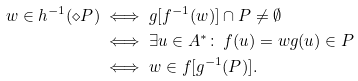Convert formula to latex. <formula><loc_0><loc_0><loc_500><loc_500>w \in h ^ { - 1 } ( \diamond P ) & \iff g [ f ^ { - 1 } ( w ) ] \cap P \neq \emptyset \\ & \iff \exists u \in A ^ { * } \colon \ f ( u ) = w g ( u ) \in P \\ & \iff w \in f [ g ^ { - 1 } ( P ) ] .</formula> 